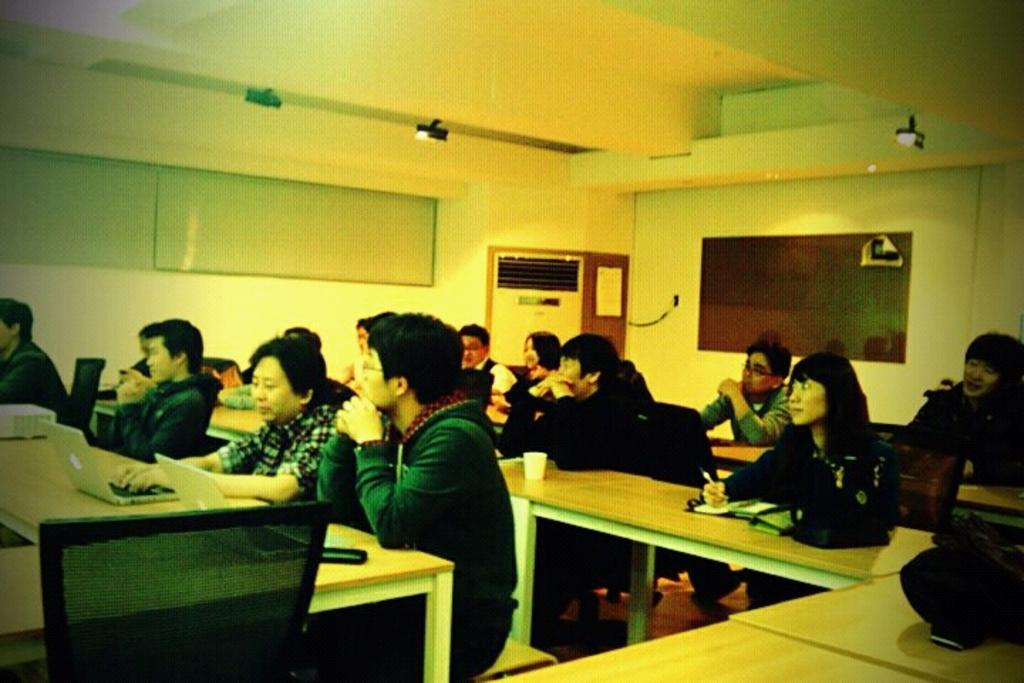What is happening in the image? There is a group of people in the image. Where are the people sitting? The people are sitting on benches. What are the people doing while sitting on the benches? The people are working on laptops. What type of chalk is being used by the people in the image? There is no chalk present in the image; the people are working on laptops. What kind of lunch is being served to the group in the image? There is no mention of lunch in the image; the people are working on laptops while sitting on benches. 